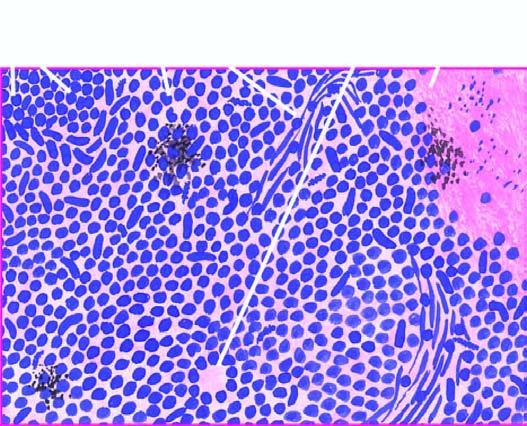re the individual tumour cells small, uniform, lymphocyte-like with scanty cytoplasm?
Answer the question using a single word or phrase. Yes 